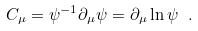<formula> <loc_0><loc_0><loc_500><loc_500>C _ { \mu } = \psi ^ { - 1 } \partial _ { \mu } \psi = \partial _ { \mu } \ln \psi \ .</formula> 